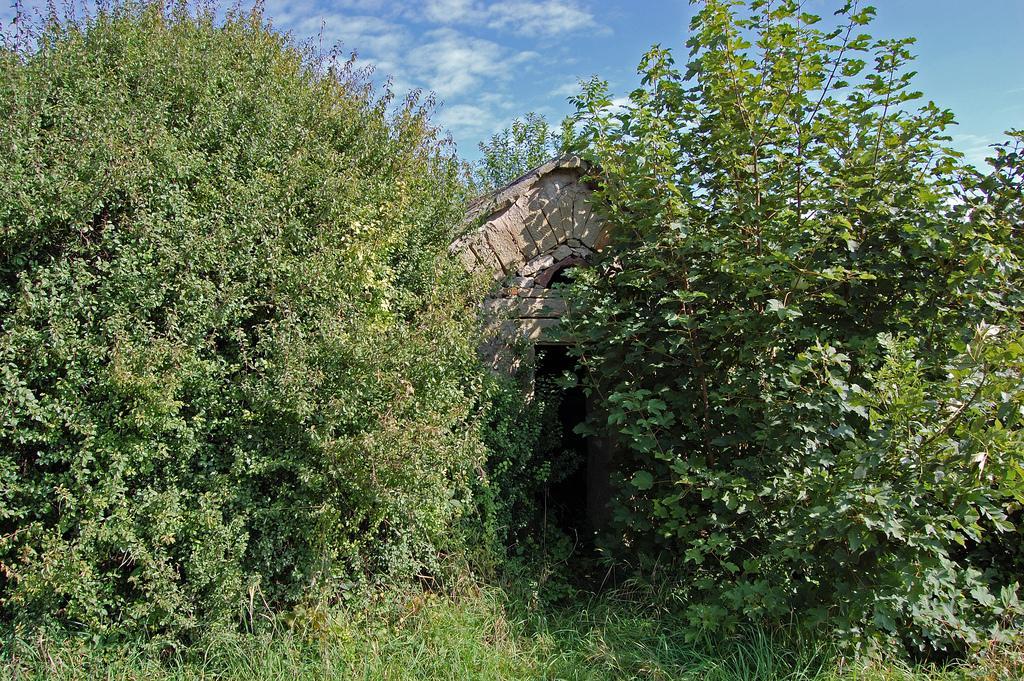Please provide a concise description of this image. In this image, we can see house, trees and plants. Background there is the sky. 